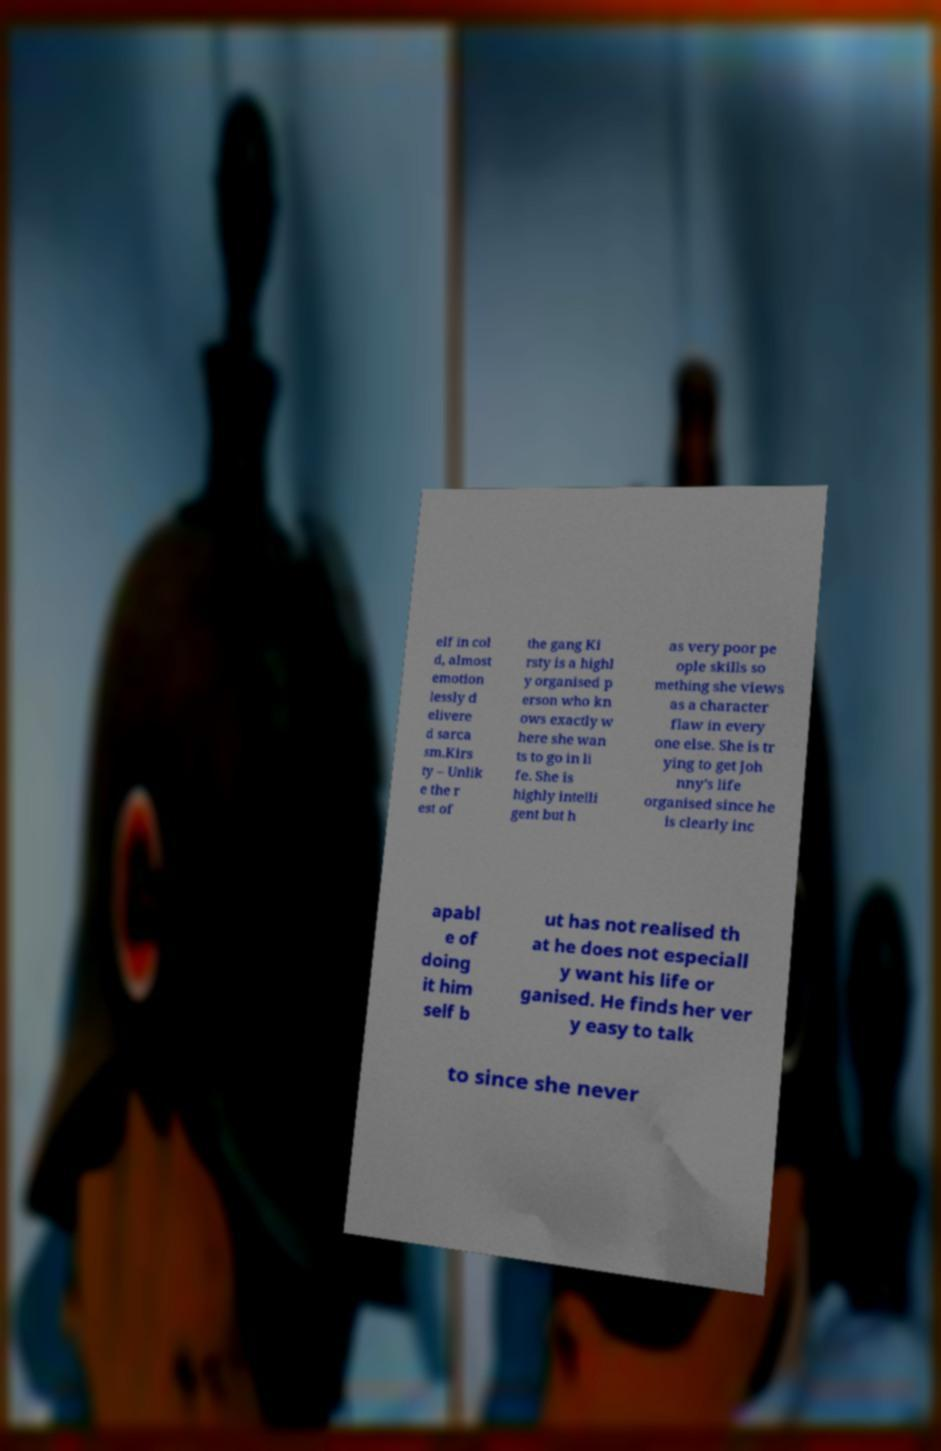Can you accurately transcribe the text from the provided image for me? elf in col d, almost emotion lessly d elivere d sarca sm.Kirs ty – Unlik e the r est of the gang Ki rsty is a highl y organised p erson who kn ows exactly w here she wan ts to go in li fe. She is highly intelli gent but h as very poor pe ople skills so mething she views as a character flaw in every one else. She is tr ying to get Joh nny's life organised since he is clearly inc apabl e of doing it him self b ut has not realised th at he does not especiall y want his life or ganised. He finds her ver y easy to talk to since she never 